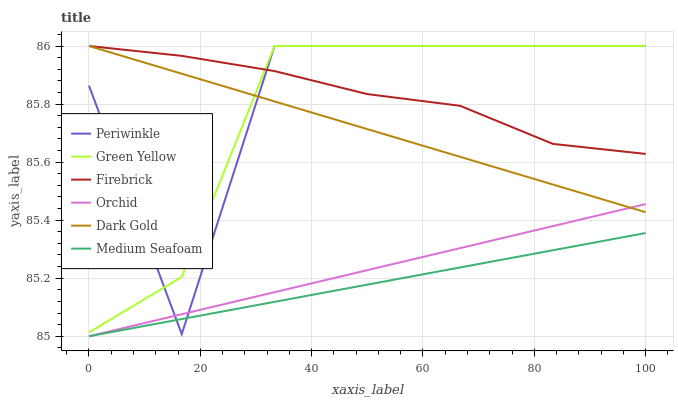Does Periwinkle have the minimum area under the curve?
Answer yes or no. No. Does Periwinkle have the maximum area under the curve?
Answer yes or no. No. Is Firebrick the smoothest?
Answer yes or no. No. Is Firebrick the roughest?
Answer yes or no. No. Does Periwinkle have the lowest value?
Answer yes or no. No. Does Medium Seafoam have the highest value?
Answer yes or no. No. Is Medium Seafoam less than Dark Gold?
Answer yes or no. Yes. Is Green Yellow greater than Orchid?
Answer yes or no. Yes. Does Medium Seafoam intersect Dark Gold?
Answer yes or no. No. 